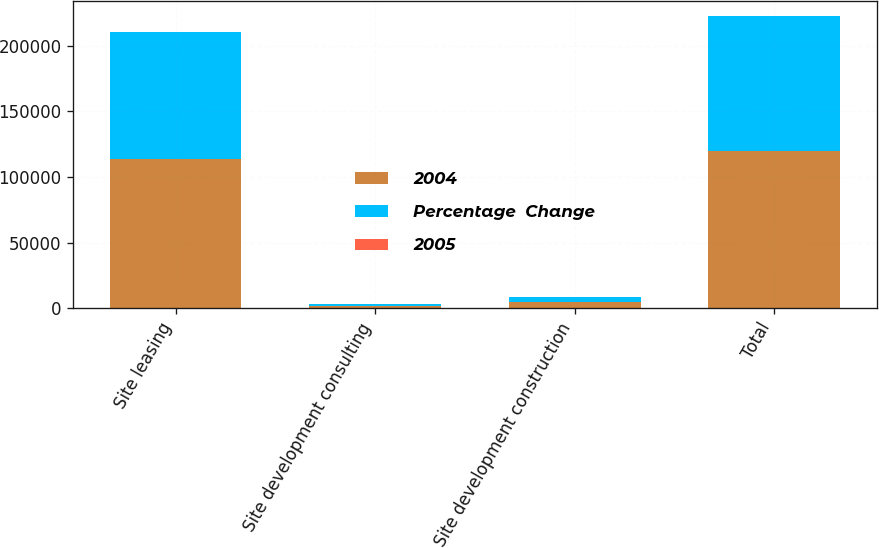Convert chart. <chart><loc_0><loc_0><loc_500><loc_500><stacked_bar_chart><ecel><fcel>Site leasing<fcel>Site development consulting<fcel>Site development construction<fcel>Total<nl><fcel>2004<fcel>114018<fcel>1545<fcel>4476<fcel>120039<nl><fcel>Percentage  Change<fcel>96721<fcel>1688<fcel>4392<fcel>102801<nl><fcel>2005<fcel>17.9<fcel>8.5<fcel>1.9<fcel>16.8<nl></chart> 